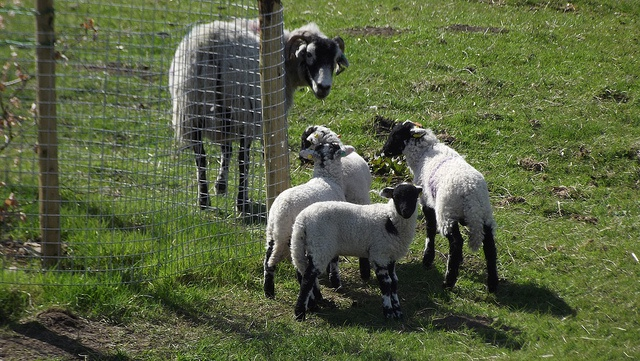Describe the objects in this image and their specific colors. I can see sheep in olive, black, gray, darkgray, and lightgray tones, sheep in olive, black, purple, lightgray, and darkgray tones, sheep in olive, black, gray, lightgray, and darkgray tones, sheep in olive, gray, lightgray, black, and darkgray tones, and sheep in olive, gray, black, lightgray, and darkgray tones in this image. 